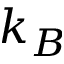<formula> <loc_0><loc_0><loc_500><loc_500>k _ { B }</formula> 